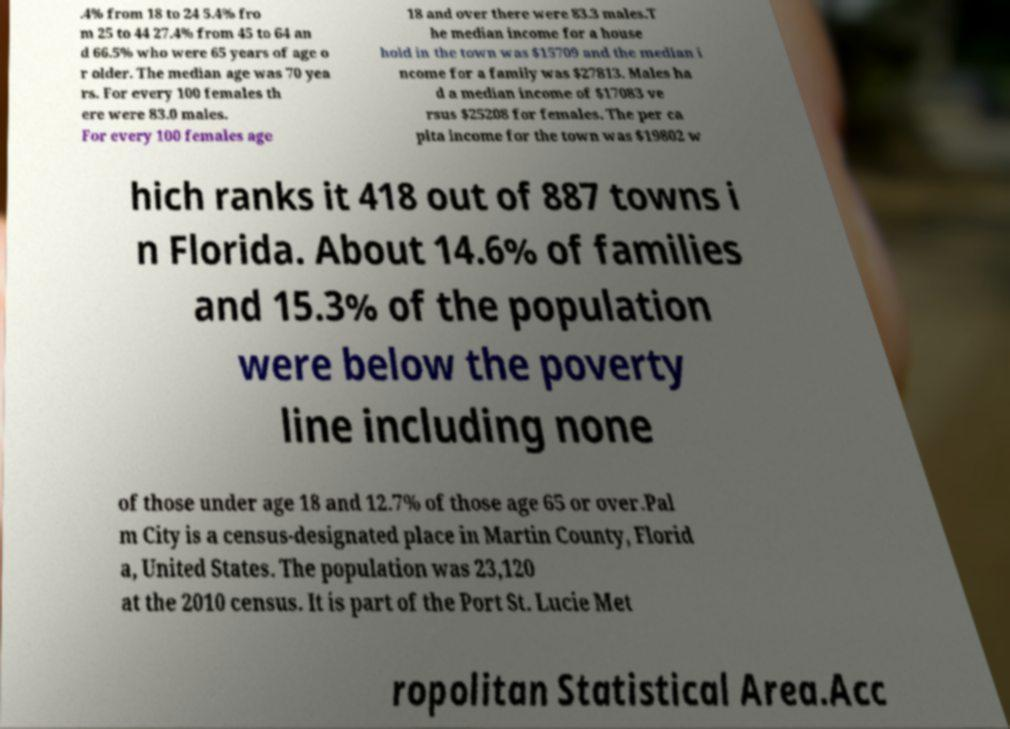I need the written content from this picture converted into text. Can you do that? .4% from 18 to 24 5.4% fro m 25 to 44 27.4% from 45 to 64 an d 66.5% who were 65 years of age o r older. The median age was 70 yea rs. For every 100 females th ere were 83.0 males. For every 100 females age 18 and over there were 83.3 males.T he median income for a house hold in the town was $15709 and the median i ncome for a family was $27813. Males ha d a median income of $17083 ve rsus $25208 for females. The per ca pita income for the town was $19802 w hich ranks it 418 out of 887 towns i n Florida. About 14.6% of families and 15.3% of the population were below the poverty line including none of those under age 18 and 12.7% of those age 65 or over.Pal m City is a census-designated place in Martin County, Florid a, United States. The population was 23,120 at the 2010 census. It is part of the Port St. Lucie Met ropolitan Statistical Area.Acc 